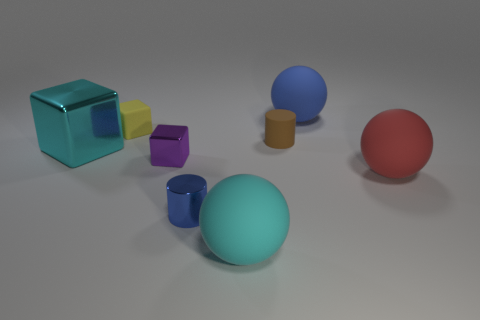What number of large blue things are the same shape as the cyan matte object?
Provide a succinct answer. 1. There is a ball that is behind the brown matte cylinder; is it the same color as the ball in front of the red sphere?
Provide a short and direct response. No. What material is the purple cube that is the same size as the metallic cylinder?
Offer a very short reply. Metal. Are there any rubber spheres that have the same size as the cyan metallic cube?
Your answer should be compact. Yes. Is the number of metal cubes to the right of the large cube less than the number of rubber cylinders?
Offer a terse response. No. Are there fewer small blue shiny objects that are to the right of the red rubber ball than small yellow blocks that are in front of the tiny purple cube?
Offer a terse response. No. How many cylinders are gray shiny things or yellow objects?
Make the answer very short. 0. Does the blue object that is behind the big red matte thing have the same material as the small blue object in front of the blue ball?
Your answer should be very brief. No. What is the shape of the purple thing that is the same size as the yellow block?
Provide a succinct answer. Cube. How many other objects are the same color as the large shiny cube?
Your answer should be very brief. 1. 